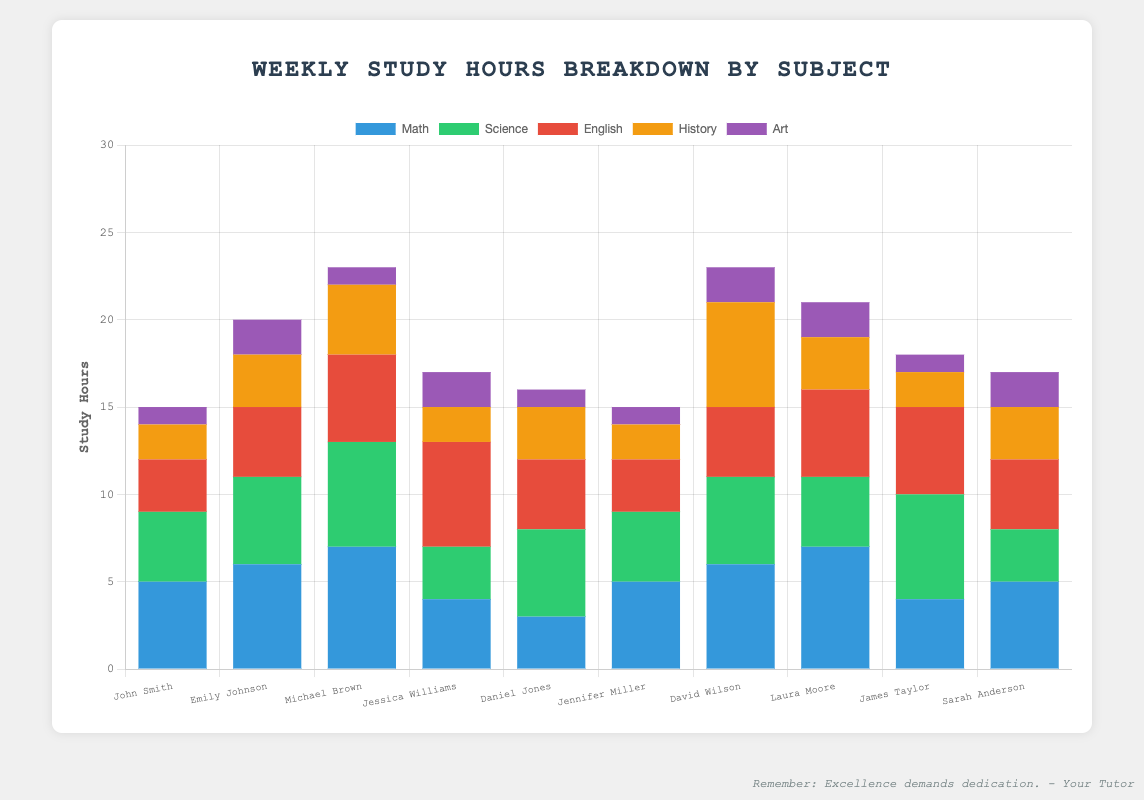Which student spends the most time studying Math? Identify the student with the tallest segment colored for Math. The student with the tallest blue bar for Math is Michael Brown, who studies for 7 hours.
Answer: Michael Brown Which subject does Laura Moore spend the least time studying? Compare all segments for Laura Moore and identify the shortest one. The shortest segment for Laura Moore, represented in purple, is for Art where she spends 2 hours.
Answer: Art Whose total study time for English and History together is the highest? Calculate the combined English and History study hours for each student and compare. Michael Brown spends 5 hours on English and 4 hours on History, totaling 9 hours, which is the highest compared to other students.
Answer: Michael Brown How many more hours does David Wilson spend on History compared to Daniel Jones? Subtract the number of hours Daniel Jones spends on History from the number of hours David Wilson does. David Wilson spends 6 hours on History, whereas Daniel Jones spends 3 hours: 6 - 3 = 3.
Answer: 3 Among all students, who has the smallest proportion of study hours spent on Science relative to their total study hours? Find the student whose green segment is smallest relative to their total bar length. Sarah Anderson studies Science for 3 hours out of her total study hours (17), making it the smallest proportion.
Answer: Sarah Anderson Which two students have identical study hours for Math, and how many hours do they study it for? Look for equal lengths of the blue segments for any two students. John Smith and Jennifer Miller both study Math for 5 hours.
Answer: John Smith and Jennifer Miller What is the average weekly study time for Math among all students? Sum the Math study hours of all students and divide by the number of students. Total Math study hours = 5 + 6 + 7 + 4 + 3 + 5 + 6 + 7 + 4 + 5 = 52. The number of students is 10, so the average is 52 / 10 = 5.2.
Answer: 5.2 Who spends the least total time studying, and how many hours do they study weekly? Identify the student with the shortest total bar length and add up all their subjects' study hours. John Smith studies a total of 15 hours (5 + 4 + 3 + 2 + 1).
Answer: John Smith If we double the hours spent by Sarah Anderson on Art, what would her total weekly study hours be? Calculate her new Art hours and then sum up her total study hours. Sarah's original total study hours = 17. Doubling Art hours means 2 hours × 2 = 4 hours. New total study hours = 5 (Math) + 3 (Science) + 4 (English) + 3 (History) + 4 (Art) = 19.
Answer: 19 